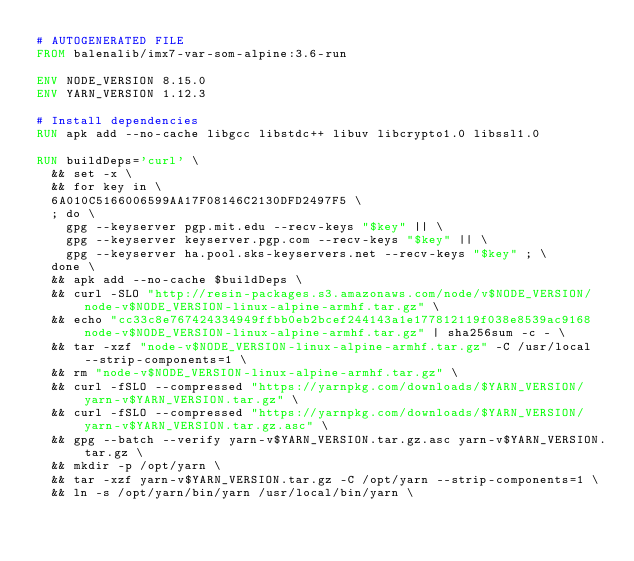Convert code to text. <code><loc_0><loc_0><loc_500><loc_500><_Dockerfile_># AUTOGENERATED FILE
FROM balenalib/imx7-var-som-alpine:3.6-run

ENV NODE_VERSION 8.15.0
ENV YARN_VERSION 1.12.3

# Install dependencies
RUN apk add --no-cache libgcc libstdc++ libuv libcrypto1.0 libssl1.0

RUN buildDeps='curl' \
	&& set -x \
	&& for key in \
	6A010C5166006599AA17F08146C2130DFD2497F5 \
	; do \
		gpg --keyserver pgp.mit.edu --recv-keys "$key" || \
		gpg --keyserver keyserver.pgp.com --recv-keys "$key" || \
		gpg --keyserver ha.pool.sks-keyservers.net --recv-keys "$key" ; \
	done \
	&& apk add --no-cache $buildDeps \
	&& curl -SLO "http://resin-packages.s3.amazonaws.com/node/v$NODE_VERSION/node-v$NODE_VERSION-linux-alpine-armhf.tar.gz" \
	&& echo "cc33c8e767424334949ffbb0eb2bcef244143a1e177812119f038e8539ac9168  node-v$NODE_VERSION-linux-alpine-armhf.tar.gz" | sha256sum -c - \
	&& tar -xzf "node-v$NODE_VERSION-linux-alpine-armhf.tar.gz" -C /usr/local --strip-components=1 \
	&& rm "node-v$NODE_VERSION-linux-alpine-armhf.tar.gz" \
	&& curl -fSLO --compressed "https://yarnpkg.com/downloads/$YARN_VERSION/yarn-v$YARN_VERSION.tar.gz" \
	&& curl -fSLO --compressed "https://yarnpkg.com/downloads/$YARN_VERSION/yarn-v$YARN_VERSION.tar.gz.asc" \
	&& gpg --batch --verify yarn-v$YARN_VERSION.tar.gz.asc yarn-v$YARN_VERSION.tar.gz \
	&& mkdir -p /opt/yarn \
	&& tar -xzf yarn-v$YARN_VERSION.tar.gz -C /opt/yarn --strip-components=1 \
	&& ln -s /opt/yarn/bin/yarn /usr/local/bin/yarn \</code> 